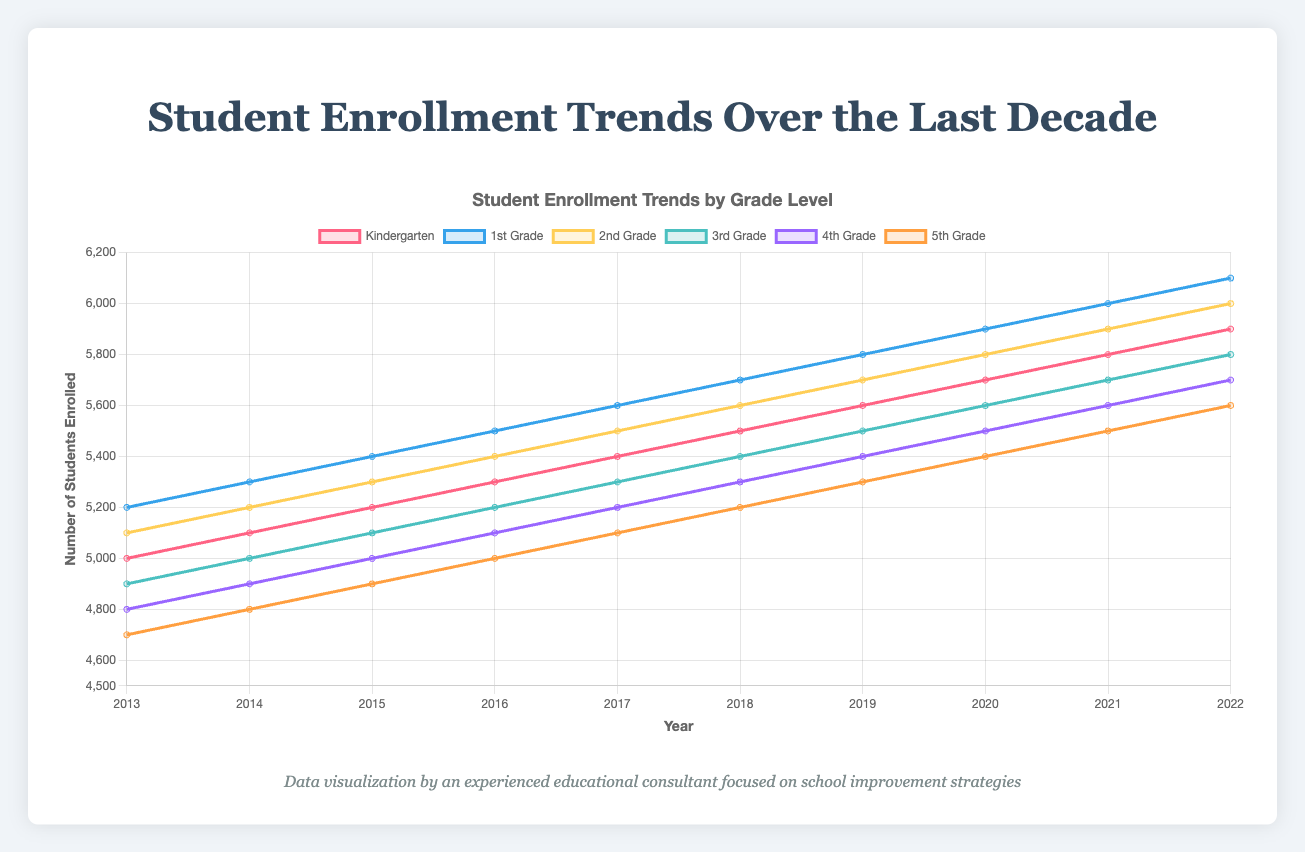How has Kindergarten enrollment changed from 2013 to 2022? To find out the change in Kindergarten enrollment, we need to look at the student enrollment numbers for Kindergarten in 2013 and compare them to the enrollment numbers in 2022. In 2013, the enrollment was 5000 students, and in 2022 it was 5900 students. The change is 5900 - 5000, which equals an increase of 900 students.
Answer: Increased by 900 Which grade had the highest number of students enrolled in 2022? To determine this, we need to look at the student enrollment numbers for each grade in 2022. Kindergarten had 5900 students, 1st Grade had 6100 students, 2nd Grade had 6000 students, 3rd Grade had 5800 students, 4th Grade had 5700 students, and 5th Grade had 5600 students. The highest enrollment number is 6100 for 1st Grade.
Answer: 1st Grade In which year did 3rd Grade enrollment see the greatest increase compared to the previous year? To identify the year with the greatest increase in 3rd Grade enrollment, we need to find the difference in enrollment numbers from one year to the next. Looking at the data: 
2014 (5000) - 2013 (4900) = 100, 2015 (5100) - 2014 (5000) = 100, 2016 (5200) - 2015 (5100) = 100, 2017 (5300) - 2016 (5200) = 100, 2018 (5400) - 2017 (5300) = 100, 2019 (5500) - 2018 (5400) = 100, 2020 (5600) - 2019 (5500) = 100, 2021 (5700) - 2020 (5600) = 100, 2022 (5800) - 2021 (5700) = 100. Each year saw an increase of 100 students, so the increase was consistent each year.
Answer: Consistent increase Between 2013 and 2022, which grade saw the smallest overall increase in student enrollment? To find the grade with the smallest increase, we need to compare the differences between 2013 and 2022 numbers for each grade:
Kindergarten: 5900 - 5000 = 900
1st Grade: 6100 - 5200 = 900
2nd Grade: 6000 - 5100 = 900
3rd Grade: 5800 - 4900 = 900
4th Grade: 5700 - 4800 = 900
5th Grade: 5600 - 4700 = 900. All grades saw an increase of 900 students.
Answer: All grades saw the same increase What is the average enrollment across all grades for the year 2020? To calculate the average enrollment for 2020, we need to sum the student enrollment numbers for all grades and then divide by the number of grades. The numbers are 5700 (Kindergarten), 5900 (1st Grade), 5800 (2nd Grade), 5600 (3rd Grade), 5500 (4th Grade), and 5400 (5th Grade). The sum is 5700 + 5900 + 5800 + 5600 + 5500 + 5400 = 33900. The average is 33900 / 6 = 5650.
Answer: 5650 Which year had the lowest enrollment for 4th Grade? To find the year with the lowest 4th-grade enrollment, we need to compare the enrollment numbers for 4th Grade across all years. The numbers are:
2013: 4800
2014: 4900
2015: 5000
2016: 5100
2017: 5200
2018: 5300
2019: 5400
2020: 5500
2021: 5600
2022: 5700. The lowest enrollment was in 2013 with 4800 students.
Answer: 2013 Compare the overall trends in student enrollment for Kindergarten and 5th Grade from 2013 to 2022. Which grade showed a more significant trend? To compare trends, we examine the starting and ending enrollment numbers and the overall increase. For Kindergarten, enrollment starts at 5000 in 2013 and ends at 5900 in 2022, with an overall increase of 900. For 5th Grade, enrollment starts at 4700 in 2013 and ends at 5600 in 2022, also with an overall increase of 900. Both grades showed the same numerical increase, but Kindergarten started with a higher enrollment number.
Answer: Both showed the same increase For the year 2018, which grade had the second-highest number of students enrolled? To find the grade with the second-highest enrollment in 2018, we list the enrollment numbers: Kindergarten: 5500, 1st Grade: 5700, 2nd Grade: 5600, 3rd Grade: 5400, 4th Grade: 5300, 5th Grade: 5200. The highest enrollment is 5700 (1st Grade), and the second-highest is 5600 (2nd Grade).
Answer: 2nd Grade 